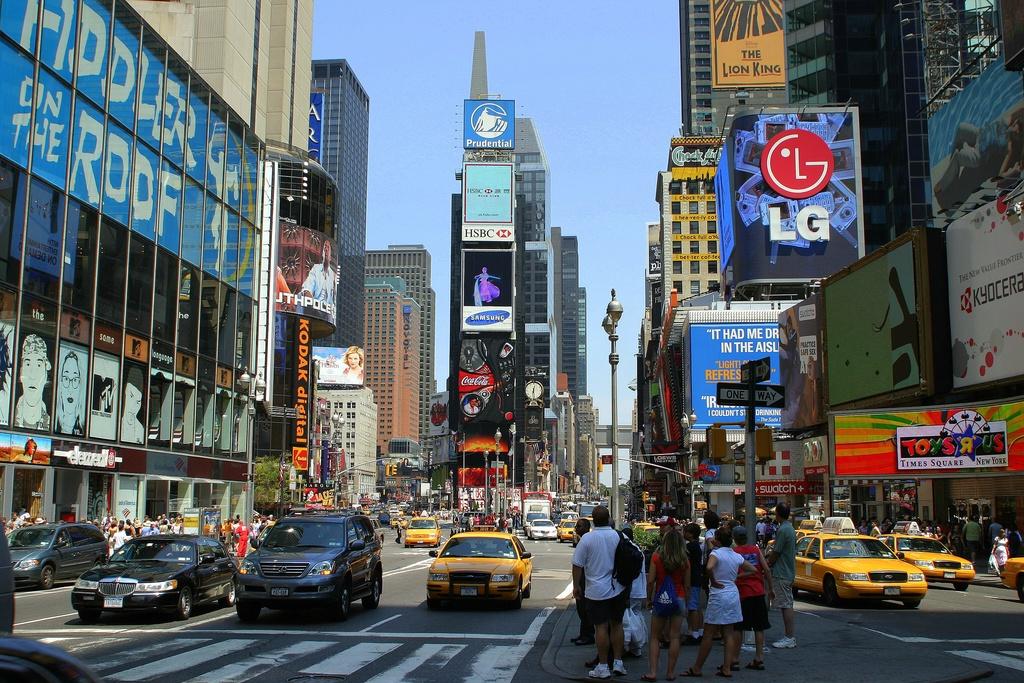What is the brand name of the logo with the red circle?
Make the answer very short. Lg. 